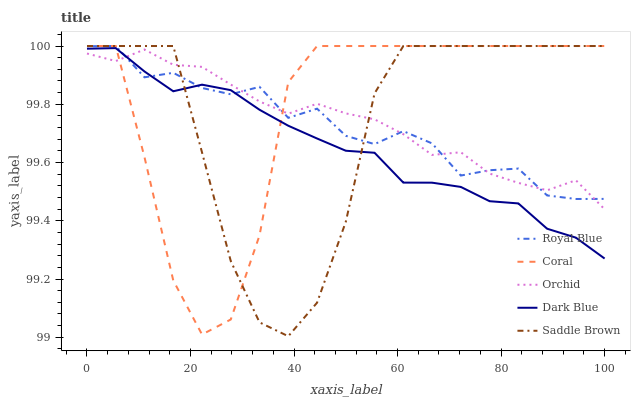Does Royal Blue have the minimum area under the curve?
Answer yes or no. No. Does Royal Blue have the maximum area under the curve?
Answer yes or no. No. Is Royal Blue the smoothest?
Answer yes or no. No. Is Royal Blue the roughest?
Answer yes or no. No. Does Coral have the lowest value?
Answer yes or no. No. Does Dark Blue have the highest value?
Answer yes or no. No. 